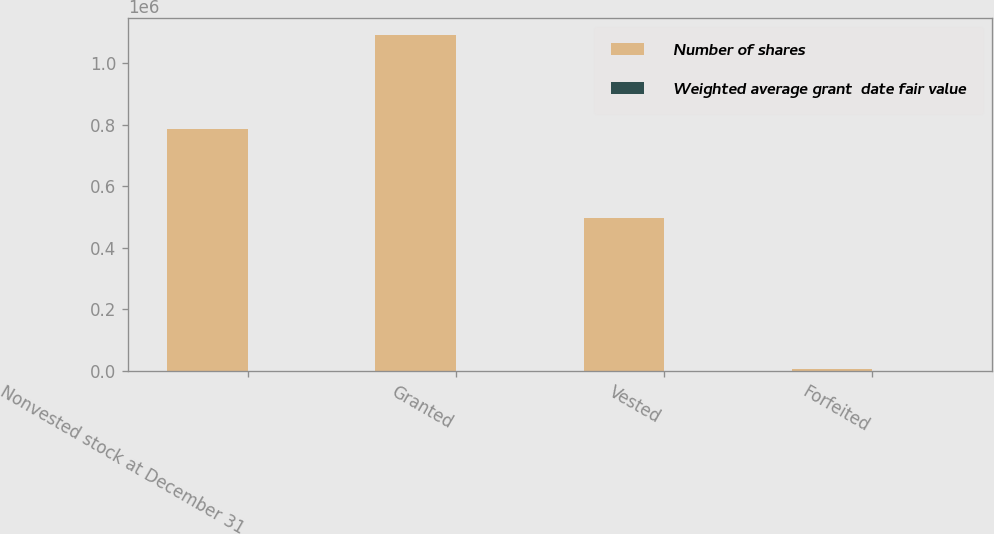<chart> <loc_0><loc_0><loc_500><loc_500><stacked_bar_chart><ecel><fcel>Nonvested stock at December 31<fcel>Granted<fcel>Vested<fcel>Forfeited<nl><fcel>Number of shares<fcel>785176<fcel>1.09184e+06<fcel>498540<fcel>5506<nl><fcel>Weighted average grant  date fair value<fcel>87.38<fcel>78.94<fcel>67.83<fcel>71.68<nl></chart> 